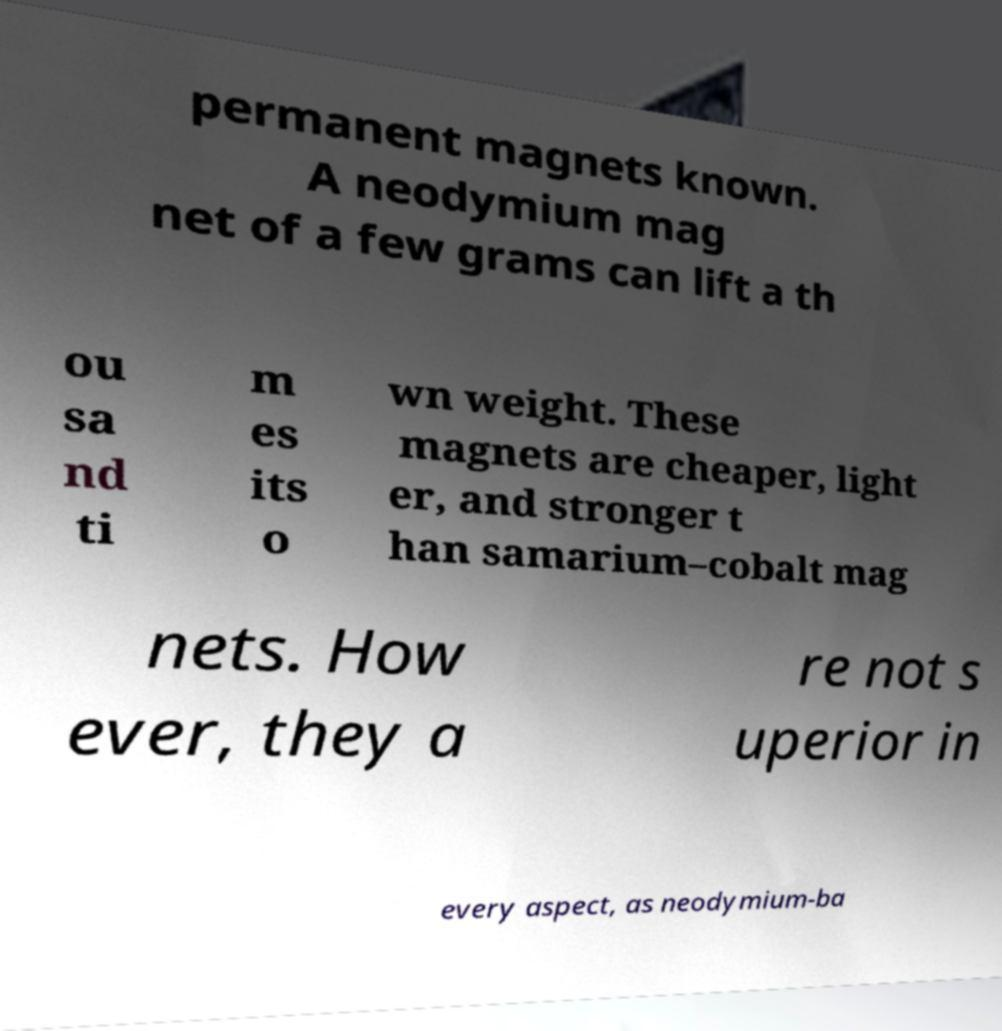Can you read and provide the text displayed in the image?This photo seems to have some interesting text. Can you extract and type it out for me? permanent magnets known. A neodymium mag net of a few grams can lift a th ou sa nd ti m es its o wn weight. These magnets are cheaper, light er, and stronger t han samarium–cobalt mag nets. How ever, they a re not s uperior in every aspect, as neodymium-ba 